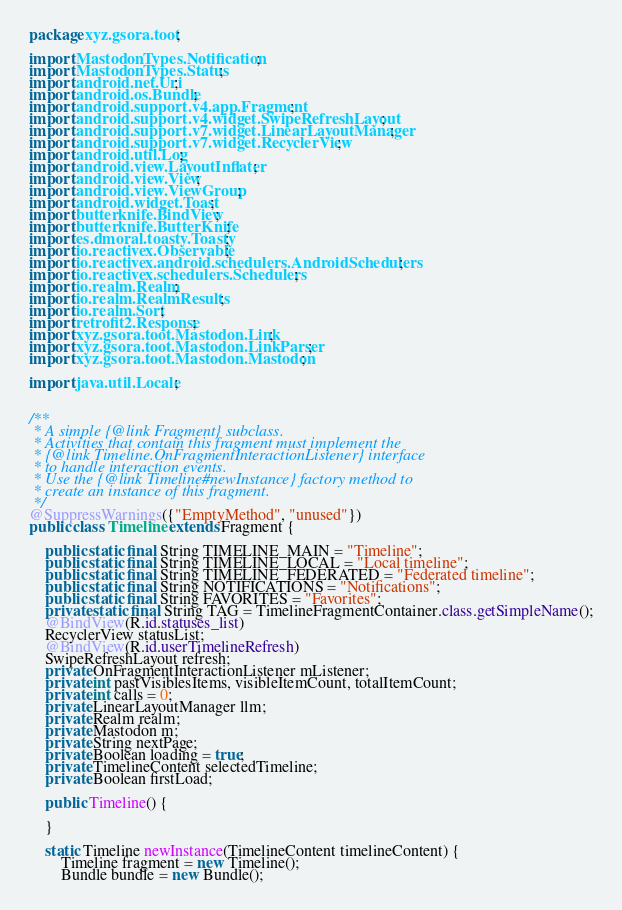<code> <loc_0><loc_0><loc_500><loc_500><_Java_>package xyz.gsora.toot;

import MastodonTypes.Notification;
import MastodonTypes.Status;
import android.net.Uri;
import android.os.Bundle;
import android.support.v4.app.Fragment;
import android.support.v4.widget.SwipeRefreshLayout;
import android.support.v7.widget.LinearLayoutManager;
import android.support.v7.widget.RecyclerView;
import android.util.Log;
import android.view.LayoutInflater;
import android.view.View;
import android.view.ViewGroup;
import android.widget.Toast;
import butterknife.BindView;
import butterknife.ButterKnife;
import es.dmoral.toasty.Toasty;
import io.reactivex.Observable;
import io.reactivex.android.schedulers.AndroidSchedulers;
import io.reactivex.schedulers.Schedulers;
import io.realm.Realm;
import io.realm.RealmResults;
import io.realm.Sort;
import retrofit2.Response;
import xyz.gsora.toot.Mastodon.Link;
import xyz.gsora.toot.Mastodon.LinkParser;
import xyz.gsora.toot.Mastodon.Mastodon;

import java.util.Locale;


/**
 * A simple {@link Fragment} subclass.
 * Activities that contain this fragment must implement the
 * {@link Timeline.OnFragmentInteractionListener} interface
 * to handle interaction events.
 * Use the {@link Timeline#newInstance} factory method to
 * create an instance of this fragment.
 */
@SuppressWarnings({"EmptyMethod", "unused"})
public class Timeline extends Fragment {

    public static final String TIMELINE_MAIN = "Timeline";
    public static final String TIMELINE_LOCAL = "Local timeline";
    public static final String TIMELINE_FEDERATED = "Federated timeline";
    public static final String NOTIFICATIONS = "Notifications";
    public static final String FAVORITES = "Favorites";
    private static final String TAG = TimelineFragmentContainer.class.getSimpleName();
    @BindView(R.id.statuses_list)
    RecyclerView statusList;
    @BindView(R.id.userTimelineRefresh)
    SwipeRefreshLayout refresh;
    private OnFragmentInteractionListener mListener;
    private int pastVisiblesItems, visibleItemCount, totalItemCount;
    private int calls = 0;
    private LinearLayoutManager llm;
    private Realm realm;
    private Mastodon m;
    private String nextPage;
    private Boolean loading = true;
    private TimelineContent selectedTimeline;
    private Boolean firstLoad;

    public Timeline() {

    }

    static Timeline newInstance(TimelineContent timelineContent) {
        Timeline fragment = new Timeline();
        Bundle bundle = new Bundle();
</code> 